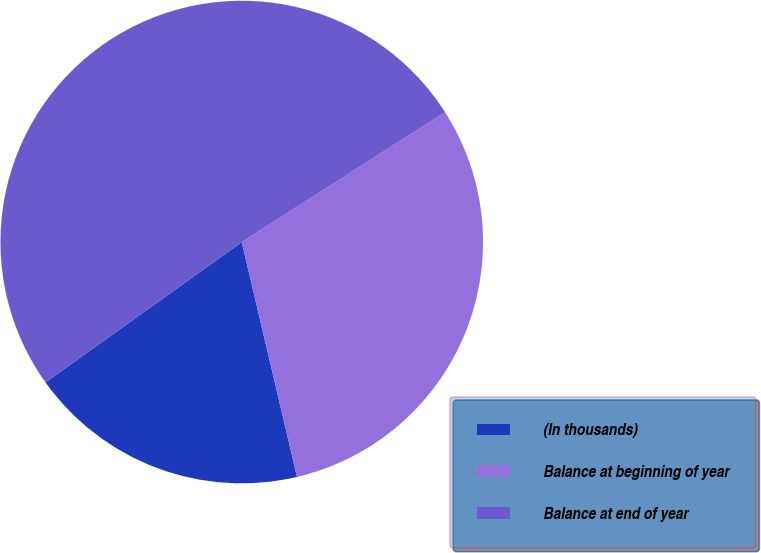<chart> <loc_0><loc_0><loc_500><loc_500><pie_chart><fcel>(In thousands)<fcel>Balance at beginning of year<fcel>Balance at end of year<nl><fcel>18.8%<fcel>30.37%<fcel>50.83%<nl></chart> 